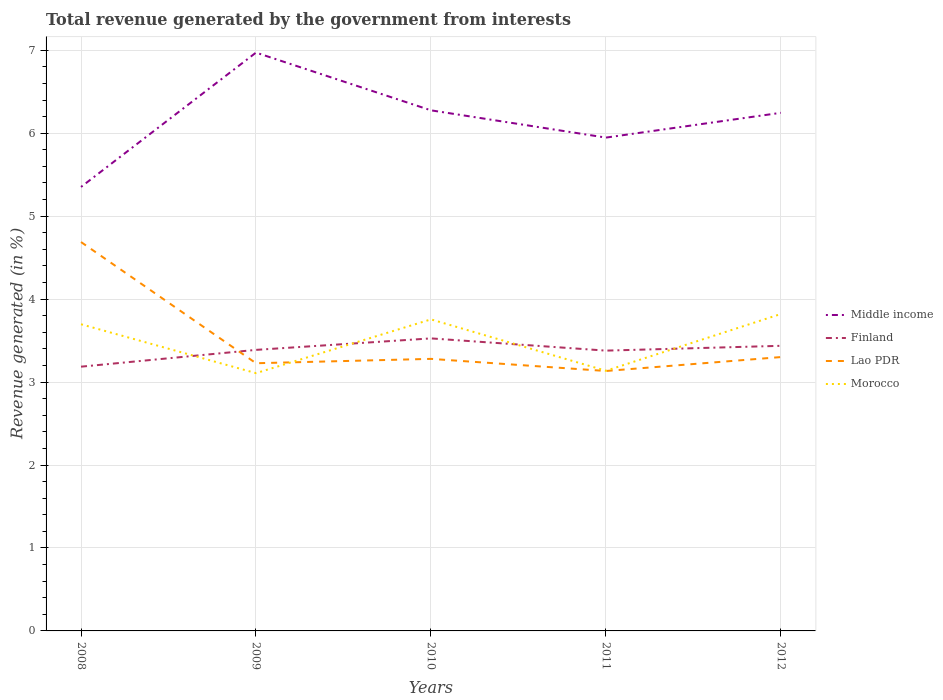How many different coloured lines are there?
Your answer should be compact. 4. Across all years, what is the maximum total revenue generated in Middle income?
Your answer should be very brief. 5.35. In which year was the total revenue generated in Morocco maximum?
Make the answer very short. 2009. What is the total total revenue generated in Lao PDR in the graph?
Offer a terse response. -0.17. What is the difference between the highest and the second highest total revenue generated in Finland?
Offer a terse response. 0.34. Is the total revenue generated in Lao PDR strictly greater than the total revenue generated in Middle income over the years?
Offer a terse response. Yes. How many years are there in the graph?
Give a very brief answer. 5. Does the graph contain any zero values?
Ensure brevity in your answer.  No. Does the graph contain grids?
Ensure brevity in your answer.  Yes. How many legend labels are there?
Offer a very short reply. 4. How are the legend labels stacked?
Offer a terse response. Vertical. What is the title of the graph?
Make the answer very short. Total revenue generated by the government from interests. Does "Algeria" appear as one of the legend labels in the graph?
Ensure brevity in your answer.  No. What is the label or title of the Y-axis?
Your answer should be compact. Revenue generated (in %). What is the Revenue generated (in %) in Middle income in 2008?
Your answer should be very brief. 5.35. What is the Revenue generated (in %) in Finland in 2008?
Provide a succinct answer. 3.19. What is the Revenue generated (in %) in Lao PDR in 2008?
Provide a short and direct response. 4.69. What is the Revenue generated (in %) in Morocco in 2008?
Your answer should be compact. 3.7. What is the Revenue generated (in %) in Middle income in 2009?
Offer a terse response. 6.97. What is the Revenue generated (in %) in Finland in 2009?
Provide a short and direct response. 3.39. What is the Revenue generated (in %) of Lao PDR in 2009?
Provide a short and direct response. 3.23. What is the Revenue generated (in %) in Morocco in 2009?
Make the answer very short. 3.11. What is the Revenue generated (in %) of Middle income in 2010?
Keep it short and to the point. 6.28. What is the Revenue generated (in %) of Finland in 2010?
Your response must be concise. 3.53. What is the Revenue generated (in %) in Lao PDR in 2010?
Your answer should be very brief. 3.28. What is the Revenue generated (in %) of Morocco in 2010?
Offer a terse response. 3.76. What is the Revenue generated (in %) of Middle income in 2011?
Your answer should be very brief. 5.95. What is the Revenue generated (in %) of Finland in 2011?
Your response must be concise. 3.38. What is the Revenue generated (in %) in Lao PDR in 2011?
Make the answer very short. 3.13. What is the Revenue generated (in %) of Morocco in 2011?
Make the answer very short. 3.14. What is the Revenue generated (in %) of Middle income in 2012?
Make the answer very short. 6.25. What is the Revenue generated (in %) in Finland in 2012?
Offer a terse response. 3.44. What is the Revenue generated (in %) of Lao PDR in 2012?
Make the answer very short. 3.3. What is the Revenue generated (in %) of Morocco in 2012?
Offer a very short reply. 3.82. Across all years, what is the maximum Revenue generated (in %) of Middle income?
Offer a terse response. 6.97. Across all years, what is the maximum Revenue generated (in %) of Finland?
Your answer should be compact. 3.53. Across all years, what is the maximum Revenue generated (in %) in Lao PDR?
Provide a short and direct response. 4.69. Across all years, what is the maximum Revenue generated (in %) of Morocco?
Give a very brief answer. 3.82. Across all years, what is the minimum Revenue generated (in %) in Middle income?
Keep it short and to the point. 5.35. Across all years, what is the minimum Revenue generated (in %) of Finland?
Your response must be concise. 3.19. Across all years, what is the minimum Revenue generated (in %) of Lao PDR?
Provide a short and direct response. 3.13. Across all years, what is the minimum Revenue generated (in %) of Morocco?
Keep it short and to the point. 3.11. What is the total Revenue generated (in %) in Middle income in the graph?
Give a very brief answer. 30.79. What is the total Revenue generated (in %) of Finland in the graph?
Keep it short and to the point. 16.92. What is the total Revenue generated (in %) of Lao PDR in the graph?
Provide a succinct answer. 17.63. What is the total Revenue generated (in %) of Morocco in the graph?
Your answer should be compact. 17.52. What is the difference between the Revenue generated (in %) of Middle income in 2008 and that in 2009?
Your response must be concise. -1.62. What is the difference between the Revenue generated (in %) in Finland in 2008 and that in 2009?
Your answer should be compact. -0.2. What is the difference between the Revenue generated (in %) in Lao PDR in 2008 and that in 2009?
Offer a terse response. 1.46. What is the difference between the Revenue generated (in %) of Morocco in 2008 and that in 2009?
Your answer should be very brief. 0.59. What is the difference between the Revenue generated (in %) of Middle income in 2008 and that in 2010?
Your answer should be compact. -0.92. What is the difference between the Revenue generated (in %) of Finland in 2008 and that in 2010?
Provide a succinct answer. -0.34. What is the difference between the Revenue generated (in %) in Lao PDR in 2008 and that in 2010?
Make the answer very short. 1.41. What is the difference between the Revenue generated (in %) in Morocco in 2008 and that in 2010?
Keep it short and to the point. -0.06. What is the difference between the Revenue generated (in %) in Middle income in 2008 and that in 2011?
Your answer should be compact. -0.59. What is the difference between the Revenue generated (in %) in Finland in 2008 and that in 2011?
Give a very brief answer. -0.19. What is the difference between the Revenue generated (in %) of Lao PDR in 2008 and that in 2011?
Ensure brevity in your answer.  1.55. What is the difference between the Revenue generated (in %) in Morocco in 2008 and that in 2011?
Provide a short and direct response. 0.56. What is the difference between the Revenue generated (in %) of Middle income in 2008 and that in 2012?
Ensure brevity in your answer.  -0.89. What is the difference between the Revenue generated (in %) of Finland in 2008 and that in 2012?
Your response must be concise. -0.25. What is the difference between the Revenue generated (in %) of Lao PDR in 2008 and that in 2012?
Keep it short and to the point. 1.39. What is the difference between the Revenue generated (in %) of Morocco in 2008 and that in 2012?
Your answer should be very brief. -0.12. What is the difference between the Revenue generated (in %) in Middle income in 2009 and that in 2010?
Ensure brevity in your answer.  0.7. What is the difference between the Revenue generated (in %) of Finland in 2009 and that in 2010?
Offer a very short reply. -0.14. What is the difference between the Revenue generated (in %) of Lao PDR in 2009 and that in 2010?
Offer a very short reply. -0.05. What is the difference between the Revenue generated (in %) of Morocco in 2009 and that in 2010?
Provide a short and direct response. -0.65. What is the difference between the Revenue generated (in %) of Middle income in 2009 and that in 2011?
Offer a terse response. 1.02. What is the difference between the Revenue generated (in %) in Finland in 2009 and that in 2011?
Offer a terse response. 0.01. What is the difference between the Revenue generated (in %) in Lao PDR in 2009 and that in 2011?
Your answer should be very brief. 0.09. What is the difference between the Revenue generated (in %) of Morocco in 2009 and that in 2011?
Your response must be concise. -0.03. What is the difference between the Revenue generated (in %) in Middle income in 2009 and that in 2012?
Your answer should be compact. 0.73. What is the difference between the Revenue generated (in %) in Finland in 2009 and that in 2012?
Your response must be concise. -0.05. What is the difference between the Revenue generated (in %) of Lao PDR in 2009 and that in 2012?
Provide a succinct answer. -0.07. What is the difference between the Revenue generated (in %) of Morocco in 2009 and that in 2012?
Give a very brief answer. -0.71. What is the difference between the Revenue generated (in %) of Middle income in 2010 and that in 2011?
Offer a very short reply. 0.33. What is the difference between the Revenue generated (in %) of Finland in 2010 and that in 2011?
Provide a short and direct response. 0.15. What is the difference between the Revenue generated (in %) of Lao PDR in 2010 and that in 2011?
Your response must be concise. 0.15. What is the difference between the Revenue generated (in %) in Morocco in 2010 and that in 2011?
Make the answer very short. 0.62. What is the difference between the Revenue generated (in %) of Middle income in 2010 and that in 2012?
Your response must be concise. 0.03. What is the difference between the Revenue generated (in %) of Finland in 2010 and that in 2012?
Make the answer very short. 0.09. What is the difference between the Revenue generated (in %) of Lao PDR in 2010 and that in 2012?
Keep it short and to the point. -0.02. What is the difference between the Revenue generated (in %) in Morocco in 2010 and that in 2012?
Your answer should be compact. -0.07. What is the difference between the Revenue generated (in %) of Middle income in 2011 and that in 2012?
Offer a very short reply. -0.3. What is the difference between the Revenue generated (in %) in Finland in 2011 and that in 2012?
Provide a succinct answer. -0.06. What is the difference between the Revenue generated (in %) in Lao PDR in 2011 and that in 2012?
Offer a very short reply. -0.17. What is the difference between the Revenue generated (in %) of Morocco in 2011 and that in 2012?
Your answer should be compact. -0.68. What is the difference between the Revenue generated (in %) of Middle income in 2008 and the Revenue generated (in %) of Finland in 2009?
Offer a terse response. 1.96. What is the difference between the Revenue generated (in %) in Middle income in 2008 and the Revenue generated (in %) in Lao PDR in 2009?
Ensure brevity in your answer.  2.13. What is the difference between the Revenue generated (in %) in Middle income in 2008 and the Revenue generated (in %) in Morocco in 2009?
Ensure brevity in your answer.  2.24. What is the difference between the Revenue generated (in %) of Finland in 2008 and the Revenue generated (in %) of Lao PDR in 2009?
Your response must be concise. -0.04. What is the difference between the Revenue generated (in %) in Finland in 2008 and the Revenue generated (in %) in Morocco in 2009?
Ensure brevity in your answer.  0.08. What is the difference between the Revenue generated (in %) in Lao PDR in 2008 and the Revenue generated (in %) in Morocco in 2009?
Provide a succinct answer. 1.58. What is the difference between the Revenue generated (in %) in Middle income in 2008 and the Revenue generated (in %) in Finland in 2010?
Keep it short and to the point. 1.83. What is the difference between the Revenue generated (in %) in Middle income in 2008 and the Revenue generated (in %) in Lao PDR in 2010?
Offer a terse response. 2.07. What is the difference between the Revenue generated (in %) of Middle income in 2008 and the Revenue generated (in %) of Morocco in 2010?
Offer a very short reply. 1.6. What is the difference between the Revenue generated (in %) of Finland in 2008 and the Revenue generated (in %) of Lao PDR in 2010?
Provide a succinct answer. -0.09. What is the difference between the Revenue generated (in %) of Finland in 2008 and the Revenue generated (in %) of Morocco in 2010?
Ensure brevity in your answer.  -0.57. What is the difference between the Revenue generated (in %) in Lao PDR in 2008 and the Revenue generated (in %) in Morocco in 2010?
Make the answer very short. 0.93. What is the difference between the Revenue generated (in %) in Middle income in 2008 and the Revenue generated (in %) in Finland in 2011?
Give a very brief answer. 1.97. What is the difference between the Revenue generated (in %) in Middle income in 2008 and the Revenue generated (in %) in Lao PDR in 2011?
Your answer should be very brief. 2.22. What is the difference between the Revenue generated (in %) of Middle income in 2008 and the Revenue generated (in %) of Morocco in 2011?
Offer a very short reply. 2.22. What is the difference between the Revenue generated (in %) in Finland in 2008 and the Revenue generated (in %) in Lao PDR in 2011?
Make the answer very short. 0.05. What is the difference between the Revenue generated (in %) in Finland in 2008 and the Revenue generated (in %) in Morocco in 2011?
Offer a very short reply. 0.05. What is the difference between the Revenue generated (in %) in Lao PDR in 2008 and the Revenue generated (in %) in Morocco in 2011?
Offer a terse response. 1.55. What is the difference between the Revenue generated (in %) in Middle income in 2008 and the Revenue generated (in %) in Finland in 2012?
Provide a succinct answer. 1.92. What is the difference between the Revenue generated (in %) of Middle income in 2008 and the Revenue generated (in %) of Lao PDR in 2012?
Offer a very short reply. 2.05. What is the difference between the Revenue generated (in %) in Middle income in 2008 and the Revenue generated (in %) in Morocco in 2012?
Your answer should be very brief. 1.53. What is the difference between the Revenue generated (in %) in Finland in 2008 and the Revenue generated (in %) in Lao PDR in 2012?
Keep it short and to the point. -0.12. What is the difference between the Revenue generated (in %) in Finland in 2008 and the Revenue generated (in %) in Morocco in 2012?
Ensure brevity in your answer.  -0.64. What is the difference between the Revenue generated (in %) of Lao PDR in 2008 and the Revenue generated (in %) of Morocco in 2012?
Offer a very short reply. 0.87. What is the difference between the Revenue generated (in %) of Middle income in 2009 and the Revenue generated (in %) of Finland in 2010?
Your response must be concise. 3.45. What is the difference between the Revenue generated (in %) of Middle income in 2009 and the Revenue generated (in %) of Lao PDR in 2010?
Provide a short and direct response. 3.69. What is the difference between the Revenue generated (in %) of Middle income in 2009 and the Revenue generated (in %) of Morocco in 2010?
Give a very brief answer. 3.22. What is the difference between the Revenue generated (in %) of Finland in 2009 and the Revenue generated (in %) of Lao PDR in 2010?
Make the answer very short. 0.11. What is the difference between the Revenue generated (in %) of Finland in 2009 and the Revenue generated (in %) of Morocco in 2010?
Provide a succinct answer. -0.37. What is the difference between the Revenue generated (in %) of Lao PDR in 2009 and the Revenue generated (in %) of Morocco in 2010?
Provide a short and direct response. -0.53. What is the difference between the Revenue generated (in %) in Middle income in 2009 and the Revenue generated (in %) in Finland in 2011?
Ensure brevity in your answer.  3.59. What is the difference between the Revenue generated (in %) of Middle income in 2009 and the Revenue generated (in %) of Lao PDR in 2011?
Your answer should be compact. 3.84. What is the difference between the Revenue generated (in %) in Middle income in 2009 and the Revenue generated (in %) in Morocco in 2011?
Ensure brevity in your answer.  3.84. What is the difference between the Revenue generated (in %) of Finland in 2009 and the Revenue generated (in %) of Lao PDR in 2011?
Your response must be concise. 0.25. What is the difference between the Revenue generated (in %) of Finland in 2009 and the Revenue generated (in %) of Morocco in 2011?
Provide a short and direct response. 0.25. What is the difference between the Revenue generated (in %) in Lao PDR in 2009 and the Revenue generated (in %) in Morocco in 2011?
Offer a very short reply. 0.09. What is the difference between the Revenue generated (in %) in Middle income in 2009 and the Revenue generated (in %) in Finland in 2012?
Make the answer very short. 3.53. What is the difference between the Revenue generated (in %) in Middle income in 2009 and the Revenue generated (in %) in Lao PDR in 2012?
Make the answer very short. 3.67. What is the difference between the Revenue generated (in %) of Middle income in 2009 and the Revenue generated (in %) of Morocco in 2012?
Offer a very short reply. 3.15. What is the difference between the Revenue generated (in %) in Finland in 2009 and the Revenue generated (in %) in Lao PDR in 2012?
Make the answer very short. 0.09. What is the difference between the Revenue generated (in %) in Finland in 2009 and the Revenue generated (in %) in Morocco in 2012?
Offer a very short reply. -0.43. What is the difference between the Revenue generated (in %) of Lao PDR in 2009 and the Revenue generated (in %) of Morocco in 2012?
Your answer should be compact. -0.59. What is the difference between the Revenue generated (in %) in Middle income in 2010 and the Revenue generated (in %) in Finland in 2011?
Provide a short and direct response. 2.9. What is the difference between the Revenue generated (in %) of Middle income in 2010 and the Revenue generated (in %) of Lao PDR in 2011?
Offer a very short reply. 3.14. What is the difference between the Revenue generated (in %) of Middle income in 2010 and the Revenue generated (in %) of Morocco in 2011?
Provide a short and direct response. 3.14. What is the difference between the Revenue generated (in %) of Finland in 2010 and the Revenue generated (in %) of Lao PDR in 2011?
Offer a terse response. 0.39. What is the difference between the Revenue generated (in %) of Finland in 2010 and the Revenue generated (in %) of Morocco in 2011?
Your response must be concise. 0.39. What is the difference between the Revenue generated (in %) of Lao PDR in 2010 and the Revenue generated (in %) of Morocco in 2011?
Provide a short and direct response. 0.14. What is the difference between the Revenue generated (in %) in Middle income in 2010 and the Revenue generated (in %) in Finland in 2012?
Provide a succinct answer. 2.84. What is the difference between the Revenue generated (in %) in Middle income in 2010 and the Revenue generated (in %) in Lao PDR in 2012?
Your response must be concise. 2.97. What is the difference between the Revenue generated (in %) in Middle income in 2010 and the Revenue generated (in %) in Morocco in 2012?
Provide a short and direct response. 2.46. What is the difference between the Revenue generated (in %) of Finland in 2010 and the Revenue generated (in %) of Lao PDR in 2012?
Keep it short and to the point. 0.23. What is the difference between the Revenue generated (in %) of Finland in 2010 and the Revenue generated (in %) of Morocco in 2012?
Ensure brevity in your answer.  -0.29. What is the difference between the Revenue generated (in %) of Lao PDR in 2010 and the Revenue generated (in %) of Morocco in 2012?
Your response must be concise. -0.54. What is the difference between the Revenue generated (in %) in Middle income in 2011 and the Revenue generated (in %) in Finland in 2012?
Provide a succinct answer. 2.51. What is the difference between the Revenue generated (in %) in Middle income in 2011 and the Revenue generated (in %) in Lao PDR in 2012?
Provide a succinct answer. 2.65. What is the difference between the Revenue generated (in %) in Middle income in 2011 and the Revenue generated (in %) in Morocco in 2012?
Offer a terse response. 2.13. What is the difference between the Revenue generated (in %) of Finland in 2011 and the Revenue generated (in %) of Lao PDR in 2012?
Provide a succinct answer. 0.08. What is the difference between the Revenue generated (in %) in Finland in 2011 and the Revenue generated (in %) in Morocco in 2012?
Ensure brevity in your answer.  -0.44. What is the difference between the Revenue generated (in %) in Lao PDR in 2011 and the Revenue generated (in %) in Morocco in 2012?
Keep it short and to the point. -0.69. What is the average Revenue generated (in %) in Middle income per year?
Keep it short and to the point. 6.16. What is the average Revenue generated (in %) of Finland per year?
Your response must be concise. 3.38. What is the average Revenue generated (in %) of Lao PDR per year?
Give a very brief answer. 3.53. What is the average Revenue generated (in %) in Morocco per year?
Ensure brevity in your answer.  3.5. In the year 2008, what is the difference between the Revenue generated (in %) of Middle income and Revenue generated (in %) of Finland?
Offer a terse response. 2.17. In the year 2008, what is the difference between the Revenue generated (in %) in Middle income and Revenue generated (in %) in Lao PDR?
Give a very brief answer. 0.66. In the year 2008, what is the difference between the Revenue generated (in %) in Middle income and Revenue generated (in %) in Morocco?
Provide a succinct answer. 1.66. In the year 2008, what is the difference between the Revenue generated (in %) in Finland and Revenue generated (in %) in Lao PDR?
Your answer should be compact. -1.5. In the year 2008, what is the difference between the Revenue generated (in %) of Finland and Revenue generated (in %) of Morocco?
Your answer should be compact. -0.51. In the year 2008, what is the difference between the Revenue generated (in %) of Lao PDR and Revenue generated (in %) of Morocco?
Provide a short and direct response. 0.99. In the year 2009, what is the difference between the Revenue generated (in %) of Middle income and Revenue generated (in %) of Finland?
Your answer should be compact. 3.58. In the year 2009, what is the difference between the Revenue generated (in %) in Middle income and Revenue generated (in %) in Lao PDR?
Your response must be concise. 3.74. In the year 2009, what is the difference between the Revenue generated (in %) of Middle income and Revenue generated (in %) of Morocco?
Your answer should be very brief. 3.86. In the year 2009, what is the difference between the Revenue generated (in %) in Finland and Revenue generated (in %) in Lao PDR?
Your response must be concise. 0.16. In the year 2009, what is the difference between the Revenue generated (in %) of Finland and Revenue generated (in %) of Morocco?
Provide a succinct answer. 0.28. In the year 2009, what is the difference between the Revenue generated (in %) in Lao PDR and Revenue generated (in %) in Morocco?
Ensure brevity in your answer.  0.12. In the year 2010, what is the difference between the Revenue generated (in %) in Middle income and Revenue generated (in %) in Finland?
Ensure brevity in your answer.  2.75. In the year 2010, what is the difference between the Revenue generated (in %) of Middle income and Revenue generated (in %) of Lao PDR?
Keep it short and to the point. 3. In the year 2010, what is the difference between the Revenue generated (in %) in Middle income and Revenue generated (in %) in Morocco?
Ensure brevity in your answer.  2.52. In the year 2010, what is the difference between the Revenue generated (in %) of Finland and Revenue generated (in %) of Lao PDR?
Ensure brevity in your answer.  0.25. In the year 2010, what is the difference between the Revenue generated (in %) in Finland and Revenue generated (in %) in Morocco?
Offer a very short reply. -0.23. In the year 2010, what is the difference between the Revenue generated (in %) in Lao PDR and Revenue generated (in %) in Morocco?
Your answer should be very brief. -0.48. In the year 2011, what is the difference between the Revenue generated (in %) of Middle income and Revenue generated (in %) of Finland?
Make the answer very short. 2.57. In the year 2011, what is the difference between the Revenue generated (in %) of Middle income and Revenue generated (in %) of Lao PDR?
Offer a terse response. 2.81. In the year 2011, what is the difference between the Revenue generated (in %) of Middle income and Revenue generated (in %) of Morocco?
Offer a terse response. 2.81. In the year 2011, what is the difference between the Revenue generated (in %) in Finland and Revenue generated (in %) in Lao PDR?
Offer a terse response. 0.25. In the year 2011, what is the difference between the Revenue generated (in %) of Finland and Revenue generated (in %) of Morocco?
Provide a succinct answer. 0.24. In the year 2011, what is the difference between the Revenue generated (in %) of Lao PDR and Revenue generated (in %) of Morocco?
Offer a very short reply. -0. In the year 2012, what is the difference between the Revenue generated (in %) in Middle income and Revenue generated (in %) in Finland?
Make the answer very short. 2.81. In the year 2012, what is the difference between the Revenue generated (in %) of Middle income and Revenue generated (in %) of Lao PDR?
Offer a terse response. 2.94. In the year 2012, what is the difference between the Revenue generated (in %) in Middle income and Revenue generated (in %) in Morocco?
Provide a short and direct response. 2.43. In the year 2012, what is the difference between the Revenue generated (in %) in Finland and Revenue generated (in %) in Lao PDR?
Make the answer very short. 0.14. In the year 2012, what is the difference between the Revenue generated (in %) in Finland and Revenue generated (in %) in Morocco?
Offer a very short reply. -0.38. In the year 2012, what is the difference between the Revenue generated (in %) in Lao PDR and Revenue generated (in %) in Morocco?
Your answer should be very brief. -0.52. What is the ratio of the Revenue generated (in %) in Middle income in 2008 to that in 2009?
Provide a succinct answer. 0.77. What is the ratio of the Revenue generated (in %) in Finland in 2008 to that in 2009?
Ensure brevity in your answer.  0.94. What is the ratio of the Revenue generated (in %) in Lao PDR in 2008 to that in 2009?
Give a very brief answer. 1.45. What is the ratio of the Revenue generated (in %) in Morocco in 2008 to that in 2009?
Ensure brevity in your answer.  1.19. What is the ratio of the Revenue generated (in %) in Middle income in 2008 to that in 2010?
Ensure brevity in your answer.  0.85. What is the ratio of the Revenue generated (in %) in Finland in 2008 to that in 2010?
Provide a succinct answer. 0.9. What is the ratio of the Revenue generated (in %) of Lao PDR in 2008 to that in 2010?
Offer a terse response. 1.43. What is the ratio of the Revenue generated (in %) of Morocco in 2008 to that in 2010?
Keep it short and to the point. 0.98. What is the ratio of the Revenue generated (in %) in Middle income in 2008 to that in 2011?
Offer a terse response. 0.9. What is the ratio of the Revenue generated (in %) of Finland in 2008 to that in 2011?
Make the answer very short. 0.94. What is the ratio of the Revenue generated (in %) in Lao PDR in 2008 to that in 2011?
Provide a succinct answer. 1.5. What is the ratio of the Revenue generated (in %) of Morocco in 2008 to that in 2011?
Keep it short and to the point. 1.18. What is the ratio of the Revenue generated (in %) in Middle income in 2008 to that in 2012?
Give a very brief answer. 0.86. What is the ratio of the Revenue generated (in %) of Finland in 2008 to that in 2012?
Give a very brief answer. 0.93. What is the ratio of the Revenue generated (in %) in Lao PDR in 2008 to that in 2012?
Provide a short and direct response. 1.42. What is the ratio of the Revenue generated (in %) of Morocco in 2008 to that in 2012?
Ensure brevity in your answer.  0.97. What is the ratio of the Revenue generated (in %) in Middle income in 2009 to that in 2010?
Keep it short and to the point. 1.11. What is the ratio of the Revenue generated (in %) of Finland in 2009 to that in 2010?
Offer a terse response. 0.96. What is the ratio of the Revenue generated (in %) in Morocco in 2009 to that in 2010?
Provide a succinct answer. 0.83. What is the ratio of the Revenue generated (in %) of Middle income in 2009 to that in 2011?
Make the answer very short. 1.17. What is the ratio of the Revenue generated (in %) in Finland in 2009 to that in 2011?
Make the answer very short. 1. What is the ratio of the Revenue generated (in %) of Lao PDR in 2009 to that in 2011?
Provide a succinct answer. 1.03. What is the ratio of the Revenue generated (in %) in Morocco in 2009 to that in 2011?
Offer a very short reply. 0.99. What is the ratio of the Revenue generated (in %) in Middle income in 2009 to that in 2012?
Your response must be concise. 1.12. What is the ratio of the Revenue generated (in %) of Finland in 2009 to that in 2012?
Offer a very short reply. 0.99. What is the ratio of the Revenue generated (in %) in Lao PDR in 2009 to that in 2012?
Keep it short and to the point. 0.98. What is the ratio of the Revenue generated (in %) of Morocco in 2009 to that in 2012?
Offer a terse response. 0.81. What is the ratio of the Revenue generated (in %) of Middle income in 2010 to that in 2011?
Offer a terse response. 1.06. What is the ratio of the Revenue generated (in %) in Finland in 2010 to that in 2011?
Give a very brief answer. 1.04. What is the ratio of the Revenue generated (in %) of Lao PDR in 2010 to that in 2011?
Give a very brief answer. 1.05. What is the ratio of the Revenue generated (in %) in Morocco in 2010 to that in 2011?
Offer a terse response. 1.2. What is the ratio of the Revenue generated (in %) in Finland in 2010 to that in 2012?
Your answer should be very brief. 1.03. What is the ratio of the Revenue generated (in %) in Middle income in 2011 to that in 2012?
Provide a succinct answer. 0.95. What is the ratio of the Revenue generated (in %) of Finland in 2011 to that in 2012?
Provide a succinct answer. 0.98. What is the ratio of the Revenue generated (in %) in Lao PDR in 2011 to that in 2012?
Your answer should be very brief. 0.95. What is the ratio of the Revenue generated (in %) in Morocco in 2011 to that in 2012?
Keep it short and to the point. 0.82. What is the difference between the highest and the second highest Revenue generated (in %) in Middle income?
Offer a very short reply. 0.7. What is the difference between the highest and the second highest Revenue generated (in %) in Finland?
Your answer should be very brief. 0.09. What is the difference between the highest and the second highest Revenue generated (in %) of Lao PDR?
Your answer should be compact. 1.39. What is the difference between the highest and the second highest Revenue generated (in %) in Morocco?
Your answer should be compact. 0.07. What is the difference between the highest and the lowest Revenue generated (in %) of Middle income?
Your response must be concise. 1.62. What is the difference between the highest and the lowest Revenue generated (in %) in Finland?
Offer a very short reply. 0.34. What is the difference between the highest and the lowest Revenue generated (in %) in Lao PDR?
Provide a succinct answer. 1.55. What is the difference between the highest and the lowest Revenue generated (in %) of Morocco?
Your response must be concise. 0.71. 